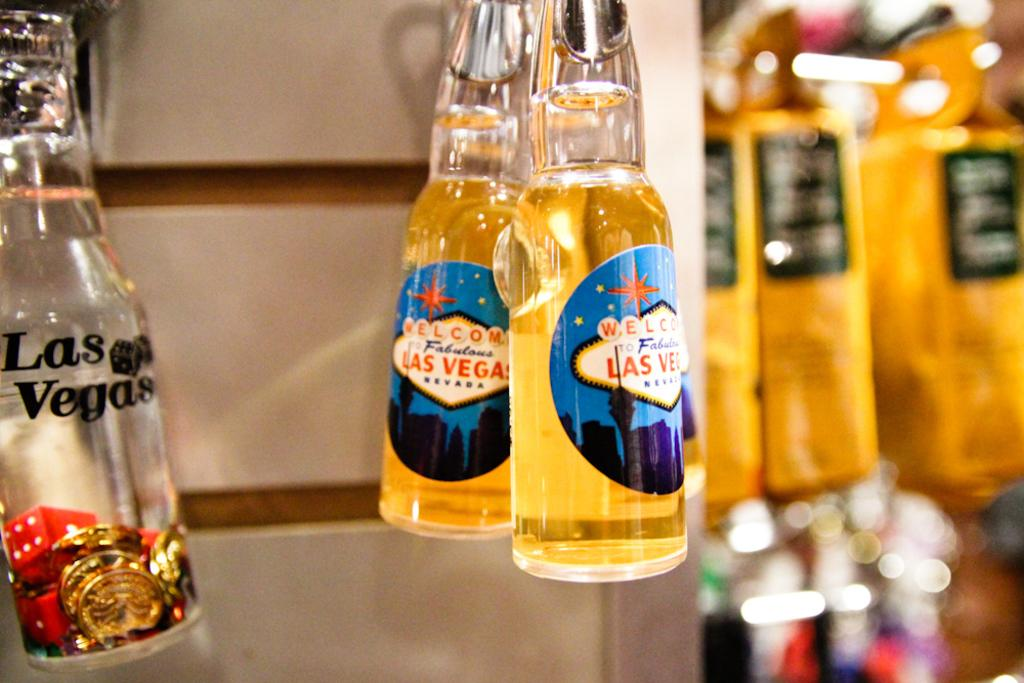<image>
Give a short and clear explanation of the subsequent image. Two bottles of Welcome to Fabulous Las Vegas Nevada beers are on display 